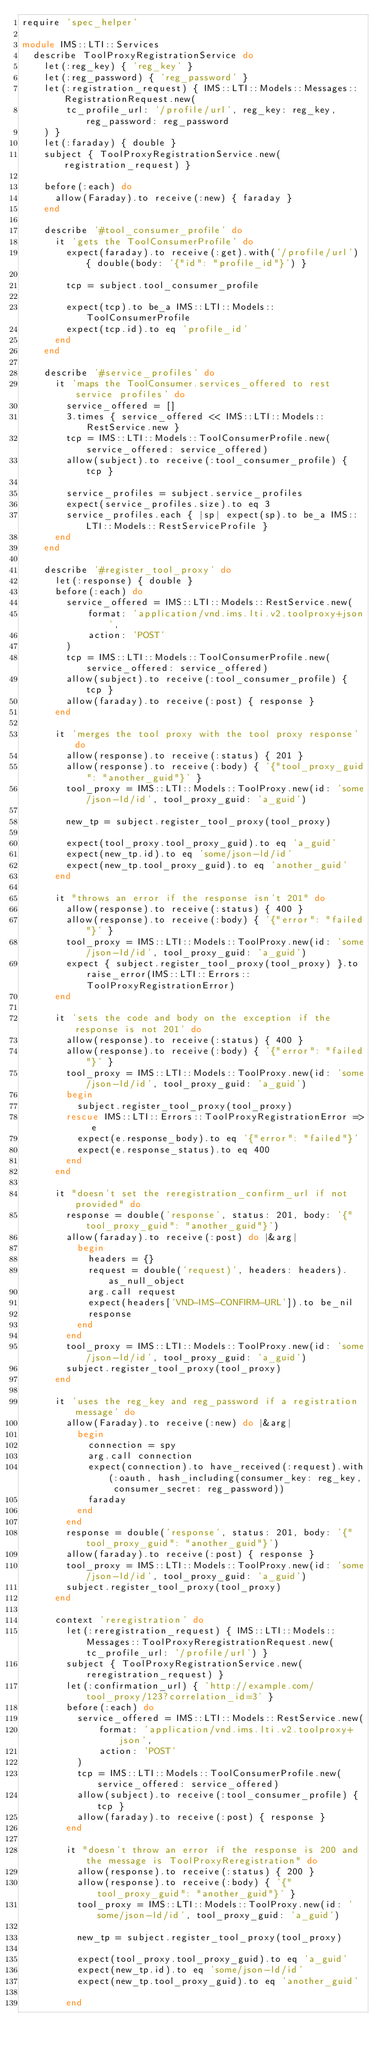Convert code to text. <code><loc_0><loc_0><loc_500><loc_500><_Ruby_>require 'spec_helper'

module IMS::LTI::Services
  describe ToolProxyRegistrationService do
    let(:reg_key) { 'reg_key' }
    let(:reg_password) { 'reg_password' }
    let(:registration_request) { IMS::LTI::Models::Messages::RegistrationRequest.new(
        tc_profile_url: '/profile/url', reg_key: reg_key, reg_password: reg_password
    ) }
    let(:faraday) { double }
    subject { ToolProxyRegistrationService.new(registration_request) }

    before(:each) do
      allow(Faraday).to receive(:new) { faraday }
    end

    describe '#tool_consumer_profile' do
      it 'gets the ToolConsumerProfile' do
        expect(faraday).to receive(:get).with('/profile/url') { double(body: '{"id": "profile_id"}') }

        tcp = subject.tool_consumer_profile

        expect(tcp).to be_a IMS::LTI::Models::ToolConsumerProfile
        expect(tcp.id).to eq 'profile_id'
      end
    end

    describe '#service_profiles' do
      it 'maps the ToolConsumer.services_offered to rest service profiles' do
        service_offered = []
        3.times { service_offered << IMS::LTI::Models::RestService.new }
        tcp = IMS::LTI::Models::ToolConsumerProfile.new(service_offered: service_offered)
        allow(subject).to receive(:tool_consumer_profile) { tcp }

        service_profiles = subject.service_profiles
        expect(service_profiles.size).to eq 3
        service_profiles.each { |sp| expect(sp).to be_a IMS::LTI::Models::RestServiceProfile }
      end
    end

    describe '#register_tool_proxy' do
      let(:response) { double }
      before(:each) do
        service_offered = IMS::LTI::Models::RestService.new(
            format: 'application/vnd.ims.lti.v2.toolproxy+json',
            action: 'POST'
        )
        tcp = IMS::LTI::Models::ToolConsumerProfile.new(service_offered: service_offered)
        allow(subject).to receive(:tool_consumer_profile) { tcp }
        allow(faraday).to receive(:post) { response }
      end

      it 'merges the tool proxy with the tool proxy response' do
        allow(response).to receive(:status) { 201 }
        allow(response).to receive(:body) { '{"tool_proxy_guid": "another_guid"}' }
        tool_proxy = IMS::LTI::Models::ToolProxy.new(id: 'some/json-ld/id', tool_proxy_guid: 'a_guid')

        new_tp = subject.register_tool_proxy(tool_proxy)

        expect(tool_proxy.tool_proxy_guid).to eq 'a_guid'
        expect(new_tp.id).to eq 'some/json-ld/id'
        expect(new_tp.tool_proxy_guid).to eq 'another_guid'
      end

      it "throws an error if the response isn't 201" do
        allow(response).to receive(:status) { 400 }
        allow(response).to receive(:body) { '{"error": "failed"}' }
        tool_proxy = IMS::LTI::Models::ToolProxy.new(id: 'some/json-ld/id', tool_proxy_guid: 'a_guid')
        expect { subject.register_tool_proxy(tool_proxy) }.to raise_error(IMS::LTI::Errors::ToolProxyRegistrationError)
      end

      it 'sets the code and body on the exception if the response is not 201' do
        allow(response).to receive(:status) { 400 }
        allow(response).to receive(:body) { '{"error": "failed"}' }
        tool_proxy = IMS::LTI::Models::ToolProxy.new(id: 'some/json-ld/id', tool_proxy_guid: 'a_guid')
        begin
          subject.register_tool_proxy(tool_proxy)
        rescue IMS::LTI::Errors::ToolProxyRegistrationError => e
          expect(e.response_body).to eq '{"error": "failed"}'
          expect(e.response_status).to eq 400
        end
      end

      it "doesn't set the reregistration_confirm_url if not provided" do
        response = double('response', status: 201, body: '{"tool_proxy_guid": "another_guid"}')
        allow(faraday).to receive(:post) do |&arg|
          begin
            headers = {}
            request = double('request)', headers: headers).as_null_object
            arg.call request
            expect(headers['VND-IMS-CONFIRM-URL']).to be_nil
            response
          end
        end
        tool_proxy = IMS::LTI::Models::ToolProxy.new(id: 'some/json-ld/id', tool_proxy_guid: 'a_guid')
        subject.register_tool_proxy(tool_proxy)
      end

      it 'uses the reg_key and reg_password if a registration message' do
        allow(Faraday).to receive(:new) do |&arg|
          begin
            connection = spy
            arg.call connection
            expect(connection).to have_received(:request).with(:oauth, hash_including(consumer_key: reg_key, consumer_secret: reg_password))
            faraday
          end
        end
        response = double('response', status: 201, body: '{"tool_proxy_guid": "another_guid"}')
        allow(faraday).to receive(:post) { response }
        tool_proxy = IMS::LTI::Models::ToolProxy.new(id: 'some/json-ld/id', tool_proxy_guid: 'a_guid')
        subject.register_tool_proxy(tool_proxy)
      end

      context 'reregistration' do
        let(:reregistration_request) { IMS::LTI::Models::Messages::ToolProxyReregistrationRequest.new(tc_profile_url: '/profile/url') }
        subject { ToolProxyRegistrationService.new(reregistration_request) }
        let(:confirmation_url) { 'http://example.com/tool_proxy/123?correlation_id=3' }
        before(:each) do
          service_offered = IMS::LTI::Models::RestService.new(
              format: 'application/vnd.ims.lti.v2.toolproxy+json',
              action: 'POST'
          )
          tcp = IMS::LTI::Models::ToolConsumerProfile.new(service_offered: service_offered)
          allow(subject).to receive(:tool_consumer_profile) { tcp }
          allow(faraday).to receive(:post) { response }
        end

        it "doesn't throw an error if the response is 200 and the message is ToolProxyReregistration" do
          allow(response).to receive(:status) { 200 }
          allow(response).to receive(:body) { '{"tool_proxy_guid": "another_guid"}' }
          tool_proxy = IMS::LTI::Models::ToolProxy.new(id: 'some/json-ld/id', tool_proxy_guid: 'a_guid')

          new_tp = subject.register_tool_proxy(tool_proxy)

          expect(tool_proxy.tool_proxy_guid).to eq 'a_guid'
          expect(new_tp.id).to eq 'some/json-ld/id'
          expect(new_tp.tool_proxy_guid).to eq 'another_guid'

        end
</code> 